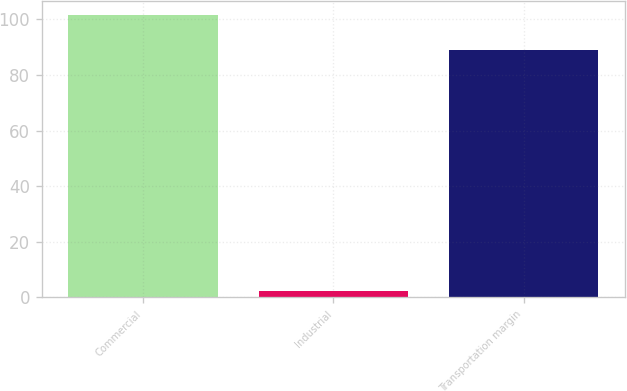Convert chart. <chart><loc_0><loc_0><loc_500><loc_500><bar_chart><fcel>Commercial<fcel>Industrial<fcel>Transportation margin<nl><fcel>101.6<fcel>2.2<fcel>88.8<nl></chart> 